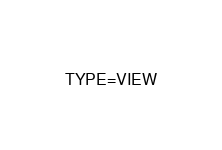<code> <loc_0><loc_0><loc_500><loc_500><_VisualBasic_>TYPE=VIEW</code> 